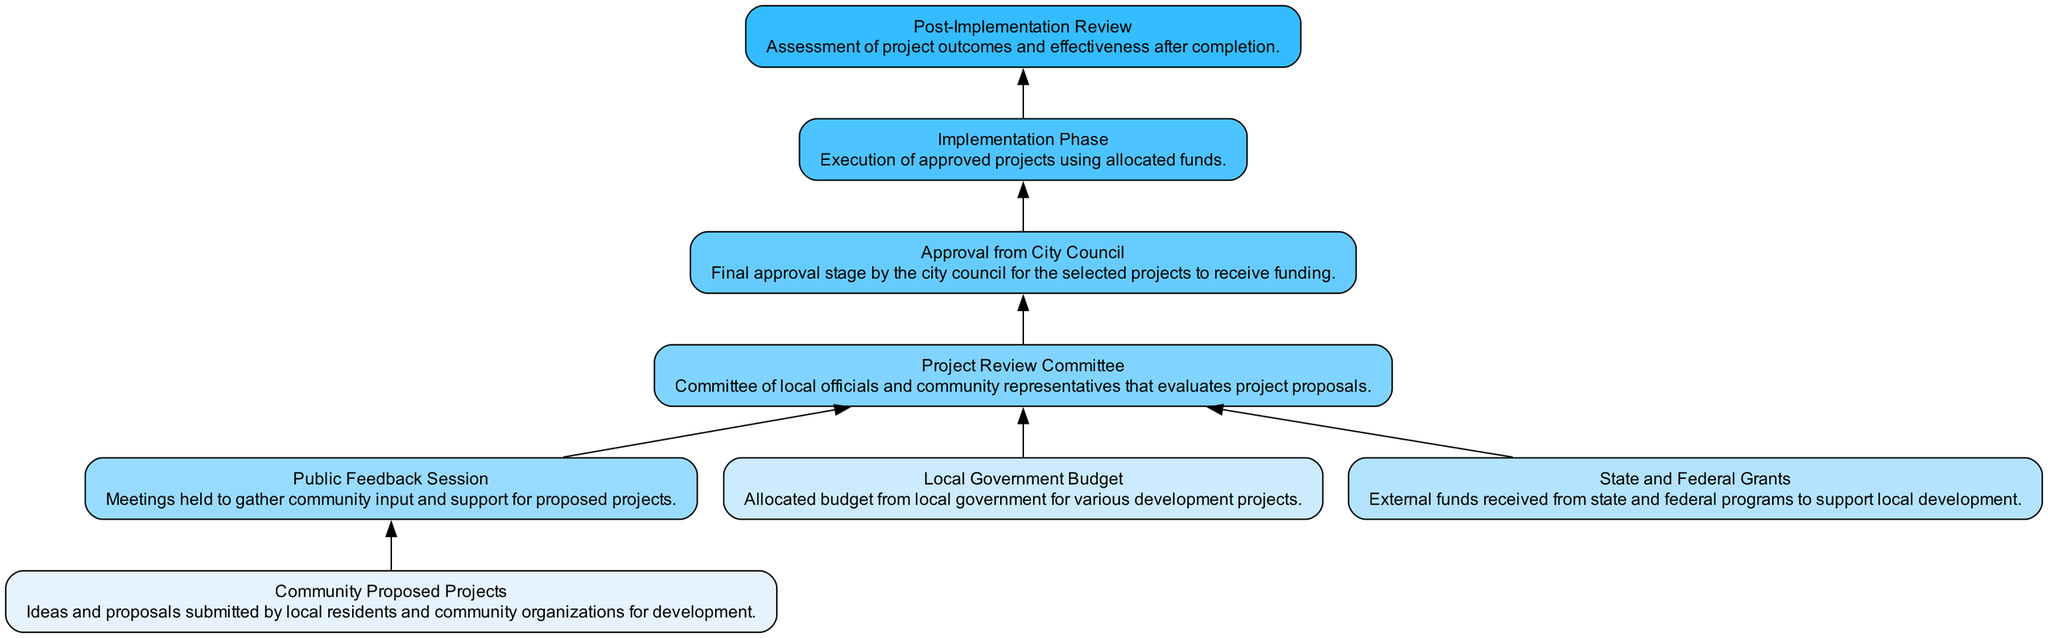What is the first step in the budget allocation process? The first step of the budget allocation process as indicated in the diagram is "Community Proposed Projects," where ideas and proposals are submitted.
Answer: Community Proposed Projects How many main components are represented in the diagram? The diagram contains a total of eight components, starting from community proposals to post-implementation review.
Answer: Eight What does the "Project Review Committee" do? The "Project Review Committee" evaluates project proposals that are submitted, facilitating the assessment of community projects based on feedback and funding sources.
Answer: Evaluates project proposals Which phase follows "Approval from City Council"? The phase that follows "Approval from City Council" in the flow is "Implementation Phase," where the approved projects are executed using the allocated funds.
Answer: Implementation Phase What are the external funding sources mentioned in the diagram? The external funding sources specified in the diagram are "State and Federal Grants," which are funds received from higher government levels to aid local development.
Answer: State and Federal Grants Which node connects the "Public Feedback Session" to the approval process? The connection from the "Public Feedback Session" to the approval process is through the "Project Review Committee," as it integrates community input before seeking council approval.
Answer: Project Review Committee What is assessed during the "Post-Implementation Review"? The assessment during the "Post-Implementation Review" involves evaluating the outcomes and effectiveness of the projects after they have been completed to ensure they met their goals.
Answer: Project outcomes and effectiveness How do local government funds influence project selection? Local government funds influence project selection by being a critical input for evaluating proposals, as they are used alongside external grants in the "Project Review Committee."
Answer: Evaluating proposals What type of meetings are held to gather community support for proposed projects? The meetings held to gather community support for proposed projects are termed "Public Feedback Sessions," where residents can express their opinions.
Answer: Public Feedback Session 